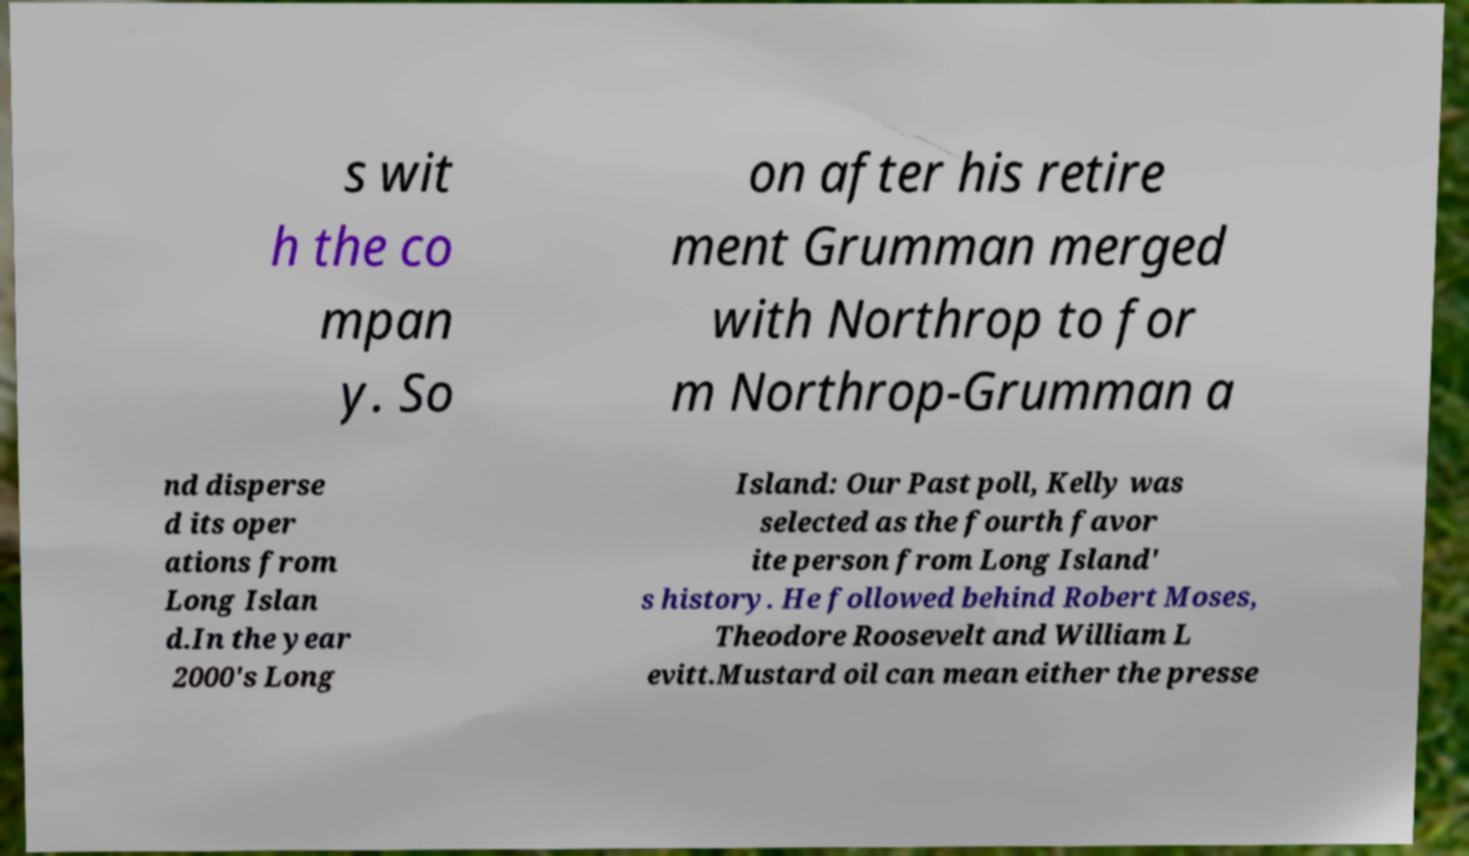Could you extract and type out the text from this image? s wit h the co mpan y. So on after his retire ment Grumman merged with Northrop to for m Northrop-Grumman a nd disperse d its oper ations from Long Islan d.In the year 2000's Long Island: Our Past poll, Kelly was selected as the fourth favor ite person from Long Island' s history. He followed behind Robert Moses, Theodore Roosevelt and William L evitt.Mustard oil can mean either the presse 